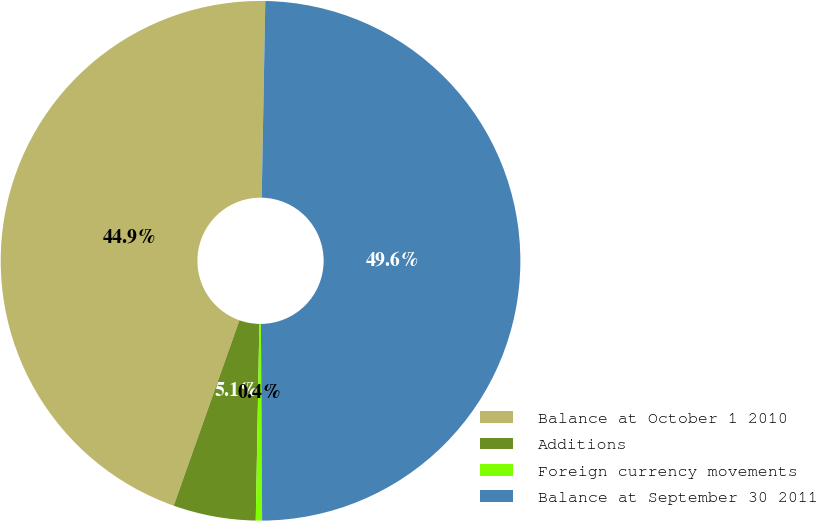<chart> <loc_0><loc_0><loc_500><loc_500><pie_chart><fcel>Balance at October 1 2010<fcel>Additions<fcel>Foreign currency movements<fcel>Balance at September 30 2011<nl><fcel>44.87%<fcel>5.13%<fcel>0.39%<fcel>49.61%<nl></chart> 